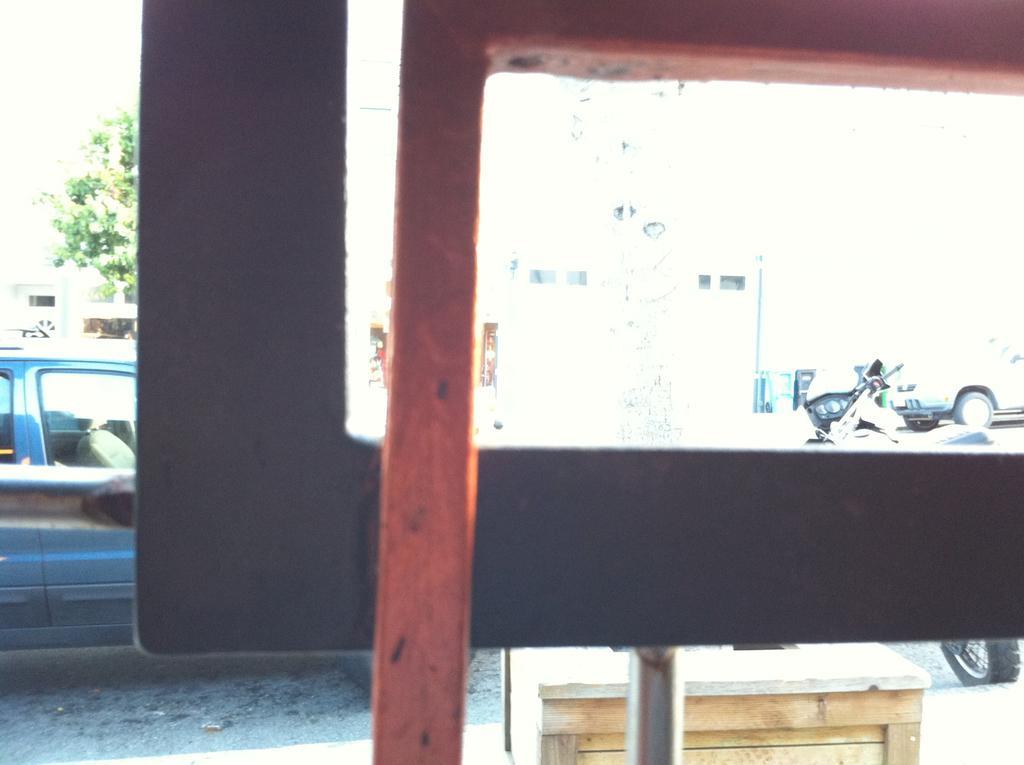How would you summarize this image in a sentence or two? In this image we can see some vehicles on the road. In the foreground we can see a metal rod. On the backside we can see a building with windows, a pole and a tree. 